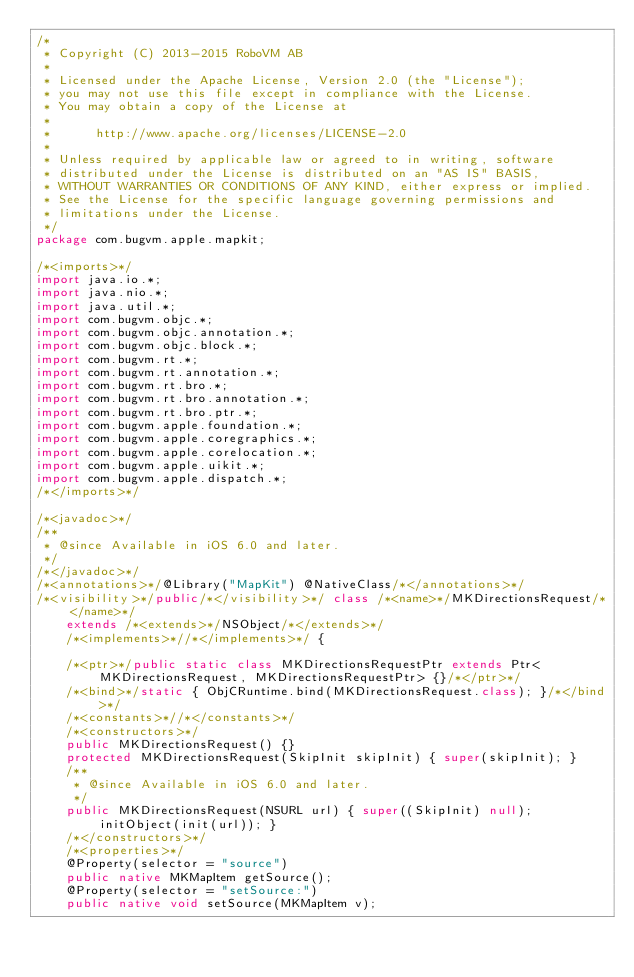<code> <loc_0><loc_0><loc_500><loc_500><_Java_>/*
 * Copyright (C) 2013-2015 RoboVM AB
 *
 * Licensed under the Apache License, Version 2.0 (the "License");
 * you may not use this file except in compliance with the License.
 * You may obtain a copy of the License at
 *
 *      http://www.apache.org/licenses/LICENSE-2.0
 *
 * Unless required by applicable law or agreed to in writing, software
 * distributed under the License is distributed on an "AS IS" BASIS,
 * WITHOUT WARRANTIES OR CONDITIONS OF ANY KIND, either express or implied.
 * See the License for the specific language governing permissions and
 * limitations under the License.
 */
package com.bugvm.apple.mapkit;

/*<imports>*/
import java.io.*;
import java.nio.*;
import java.util.*;
import com.bugvm.objc.*;
import com.bugvm.objc.annotation.*;
import com.bugvm.objc.block.*;
import com.bugvm.rt.*;
import com.bugvm.rt.annotation.*;
import com.bugvm.rt.bro.*;
import com.bugvm.rt.bro.annotation.*;
import com.bugvm.rt.bro.ptr.*;
import com.bugvm.apple.foundation.*;
import com.bugvm.apple.coregraphics.*;
import com.bugvm.apple.corelocation.*;
import com.bugvm.apple.uikit.*;
import com.bugvm.apple.dispatch.*;
/*</imports>*/

/*<javadoc>*/
/**
 * @since Available in iOS 6.0 and later.
 */
/*</javadoc>*/
/*<annotations>*/@Library("MapKit") @NativeClass/*</annotations>*/
/*<visibility>*/public/*</visibility>*/ class /*<name>*/MKDirectionsRequest/*</name>*/ 
    extends /*<extends>*/NSObject/*</extends>*/ 
    /*<implements>*//*</implements>*/ {

    /*<ptr>*/public static class MKDirectionsRequestPtr extends Ptr<MKDirectionsRequest, MKDirectionsRequestPtr> {}/*</ptr>*/
    /*<bind>*/static { ObjCRuntime.bind(MKDirectionsRequest.class); }/*</bind>*/
    /*<constants>*//*</constants>*/
    /*<constructors>*/
    public MKDirectionsRequest() {}
    protected MKDirectionsRequest(SkipInit skipInit) { super(skipInit); }
    /**
     * @since Available in iOS 6.0 and later.
     */
    public MKDirectionsRequest(NSURL url) { super((SkipInit) null); initObject(init(url)); }
    /*</constructors>*/
    /*<properties>*/
    @Property(selector = "source")
    public native MKMapItem getSource();
    @Property(selector = "setSource:")
    public native void setSource(MKMapItem v);</code> 